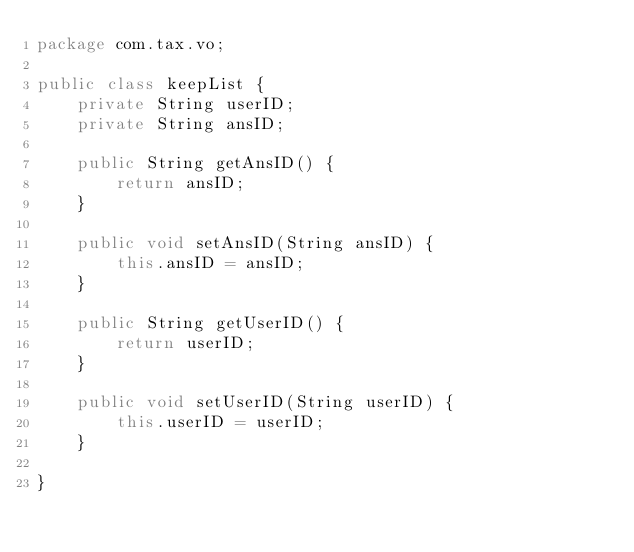<code> <loc_0><loc_0><loc_500><loc_500><_Java_>package com.tax.vo;

public class keepList {
	private String userID;
	private String ansID;
	
	public String getAnsID() {
		return ansID;
	}

	public void setAnsID(String ansID) {
		this.ansID = ansID;
	}

	public String getUserID() {
		return userID;
	}

	public void setUserID(String userID) {
		this.userID = userID;
	}
	
}
</code> 